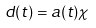<formula> <loc_0><loc_0><loc_500><loc_500>d ( t ) = a ( t ) \chi</formula> 